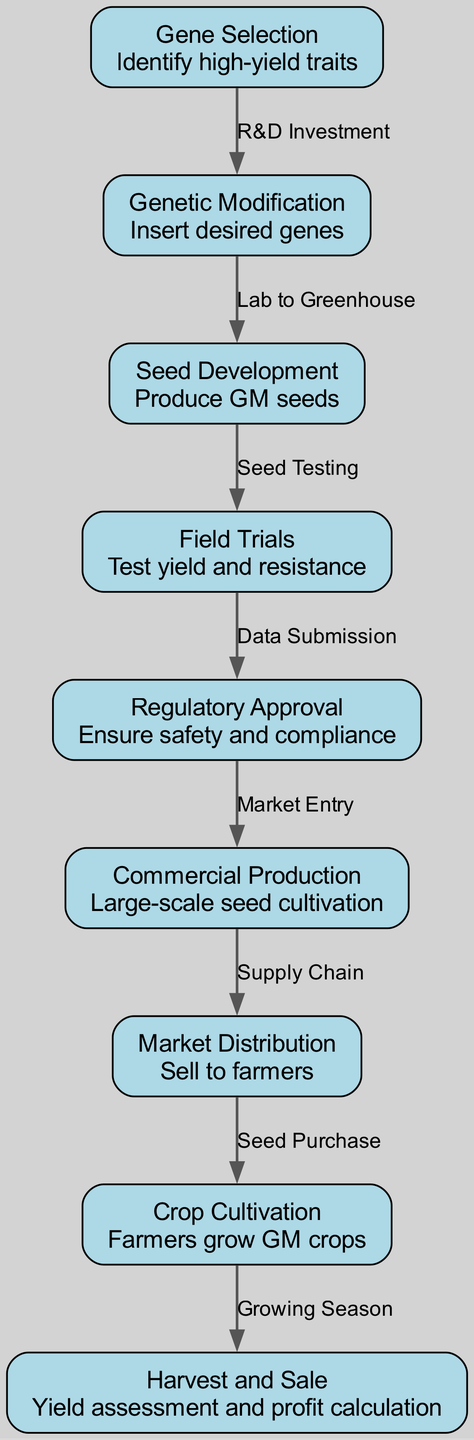What is the first step in the lifecycle? The diagram shows the first node as "Gene Selection," indicating it as the initial step in the lifecycle of a genetically modified crop.
Answer: Gene Selection How many nodes are there in the diagram? By counting the nodes listed in the data, there are a total of nine nodes depicted within the diagram.
Answer: 9 What is the label of the edge from "Field Trials" to "Regulatory Approval"? The label on that edge is "Data Submission," representing the connection between these two specific steps in the lifecycle.
Answer: Data Submission What follows "Genetic Modification" in the lifecycle? The next step indicated in the diagram after "Genetic Modification" is "Seed Development," showcasing the progression of the lifecycle.
Answer: Seed Development How many edges connect to "Market Distribution"? There is only one edge connecting to "Market Distribution," which indicates the preceding step, "Commercial Production," before reaching this phase.
Answer: 1 Which step involves large-scale seed cultivation? The node labeled "Commercial Production" pertains specifically to the phase where large-scale seed cultivation occurs, making it the correct answer.
Answer: Commercial Production What is the final step in the lifecycle? The last node in the diagram is "Harvest and Sale," marking it as the endpoint of the lifecycle of a genetically modified crop.
Answer: Harvest and Sale What step directly follows "Crop Cultivation"? Following "Crop Cultivation" in the sequence is "Harvest and Sale," indicating what comes next in the crop lifecycle.
Answer: Harvest and Sale What describes the relationship between "Gene Selection" and "Genetic Modification"? The relationship is defined by "R&D Investment," illustrating the flow of resources and efforts from gene identification to the modification process.
Answer: R&D Investment 